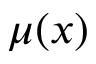<formula> <loc_0><loc_0><loc_500><loc_500>\mu ( x )</formula> 